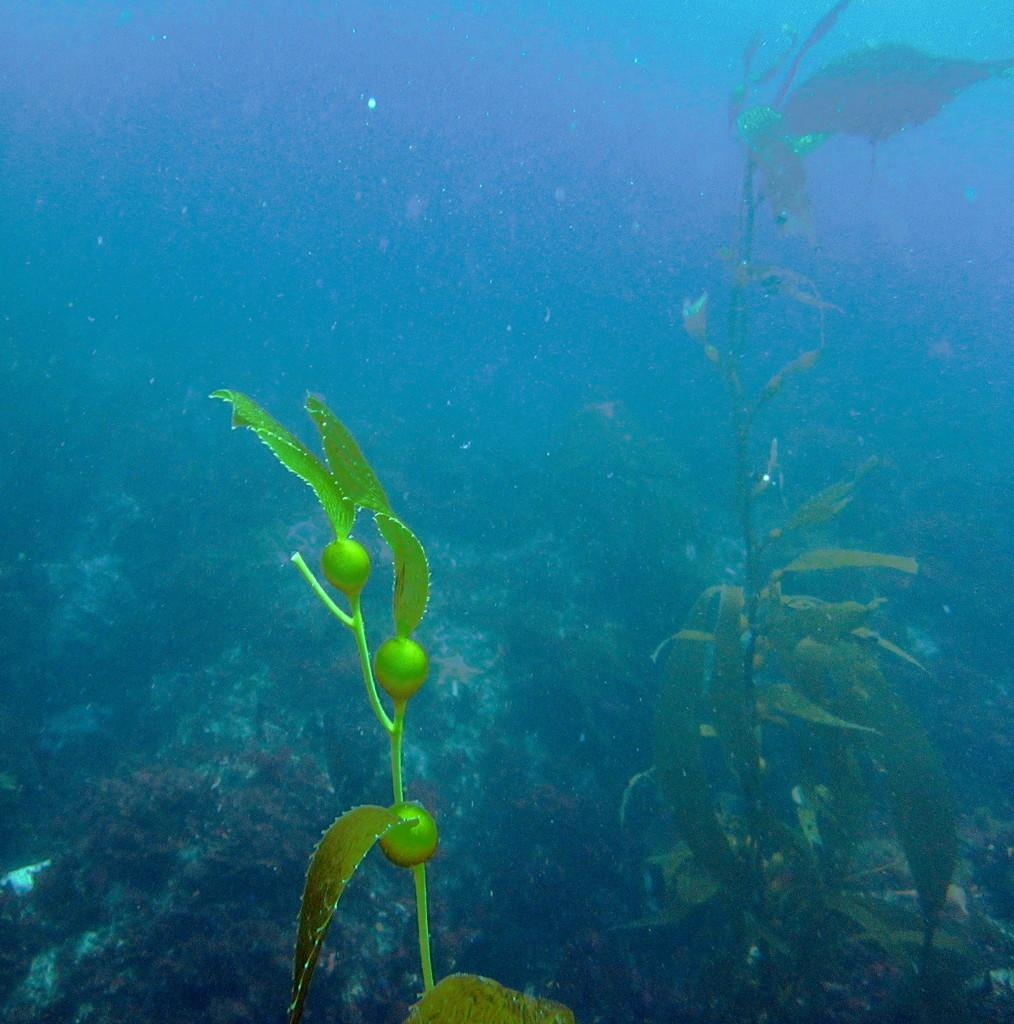What is the main subject of the image? The main subject of the image is an inside view of water. Are there any other elements present in the image besides the water? Yes, there are plants visible in front of the water. What type of humor can be seen in the image? There is no humor present in the image; it shows an inside view of water with plants in front of it. 